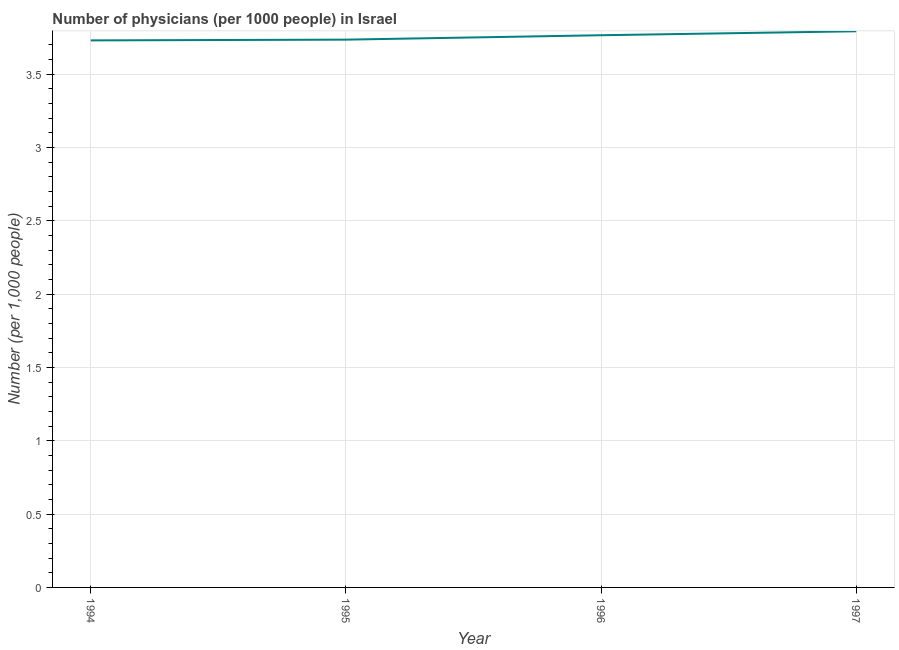What is the number of physicians in 1997?
Provide a succinct answer. 3.79. Across all years, what is the maximum number of physicians?
Provide a short and direct response. 3.79. Across all years, what is the minimum number of physicians?
Offer a terse response. 3.73. What is the sum of the number of physicians?
Your answer should be compact. 15.03. What is the difference between the number of physicians in 1995 and 1997?
Provide a succinct answer. -0.06. What is the average number of physicians per year?
Offer a terse response. 3.76. What is the median number of physicians?
Your answer should be very brief. 3.75. In how many years, is the number of physicians greater than 1.2 ?
Make the answer very short. 4. What is the ratio of the number of physicians in 1994 to that in 1996?
Offer a terse response. 0.99. Is the number of physicians in 1995 less than that in 1997?
Your answer should be compact. Yes. What is the difference between the highest and the second highest number of physicians?
Give a very brief answer. 0.03. Is the sum of the number of physicians in 1994 and 1995 greater than the maximum number of physicians across all years?
Your answer should be compact. Yes. What is the difference between the highest and the lowest number of physicians?
Your answer should be very brief. 0.06. In how many years, is the number of physicians greater than the average number of physicians taken over all years?
Provide a short and direct response. 2. Does the number of physicians monotonically increase over the years?
Ensure brevity in your answer.  Yes. How many lines are there?
Ensure brevity in your answer.  1. Are the values on the major ticks of Y-axis written in scientific E-notation?
Your answer should be compact. No. Does the graph contain grids?
Offer a terse response. Yes. What is the title of the graph?
Provide a short and direct response. Number of physicians (per 1000 people) in Israel. What is the label or title of the Y-axis?
Give a very brief answer. Number (per 1,0 people). What is the Number (per 1,000 people) of 1994?
Keep it short and to the point. 3.73. What is the Number (per 1,000 people) in 1995?
Provide a short and direct response. 3.74. What is the Number (per 1,000 people) in 1996?
Give a very brief answer. 3.77. What is the Number (per 1,000 people) in 1997?
Give a very brief answer. 3.79. What is the difference between the Number (per 1,000 people) in 1994 and 1995?
Ensure brevity in your answer.  -0.01. What is the difference between the Number (per 1,000 people) in 1994 and 1996?
Offer a terse response. -0.04. What is the difference between the Number (per 1,000 people) in 1994 and 1997?
Offer a terse response. -0.06. What is the difference between the Number (per 1,000 people) in 1995 and 1996?
Offer a very short reply. -0.03. What is the difference between the Number (per 1,000 people) in 1995 and 1997?
Provide a succinct answer. -0.06. What is the difference between the Number (per 1,000 people) in 1996 and 1997?
Provide a succinct answer. -0.03. What is the ratio of the Number (per 1,000 people) in 1994 to that in 1995?
Offer a very short reply. 1. What is the ratio of the Number (per 1,000 people) in 1994 to that in 1996?
Offer a very short reply. 0.99. What is the ratio of the Number (per 1,000 people) in 1995 to that in 1996?
Your answer should be compact. 0.99. What is the ratio of the Number (per 1,000 people) in 1995 to that in 1997?
Provide a short and direct response. 0.98. 